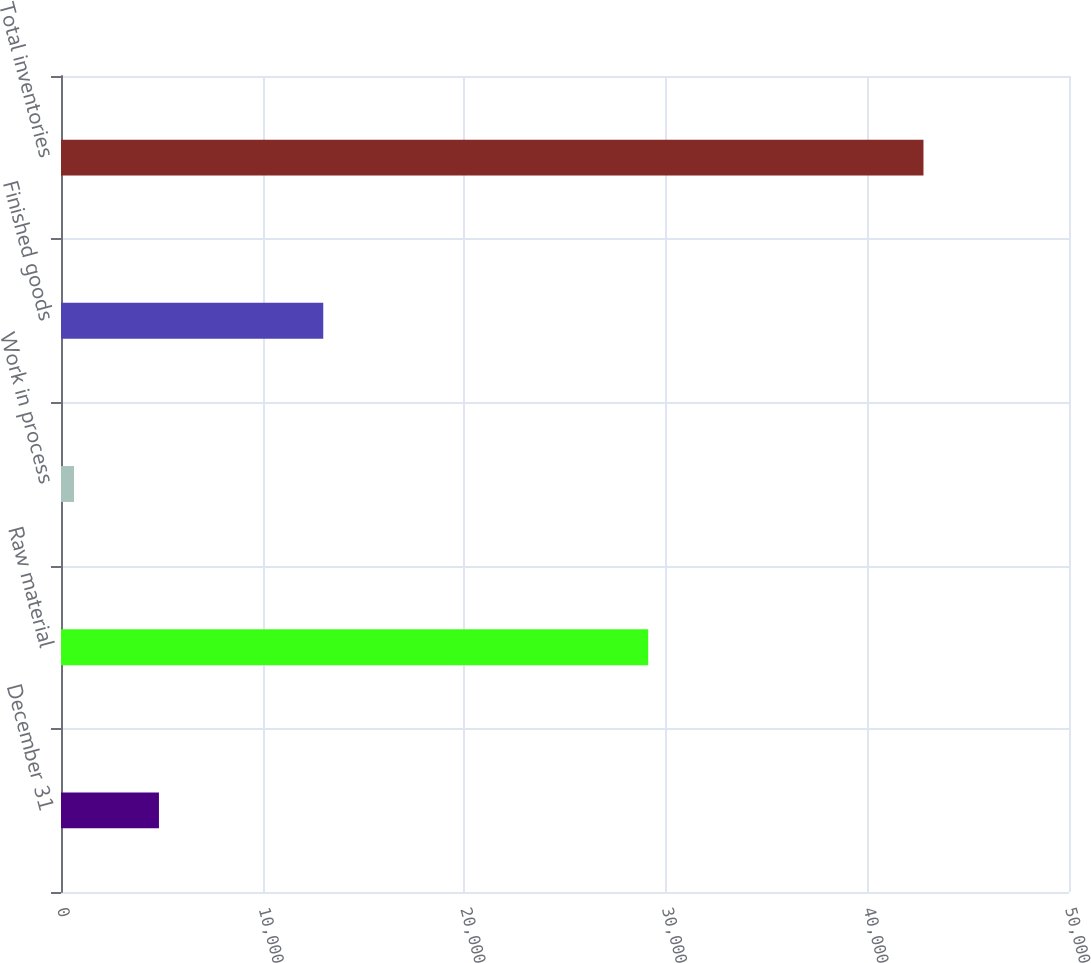Convert chart. <chart><loc_0><loc_0><loc_500><loc_500><bar_chart><fcel>December 31<fcel>Raw material<fcel>Work in process<fcel>Finished goods<fcel>Total inventories<nl><fcel>4858.6<fcel>29127<fcel>645<fcel>13009<fcel>42781<nl></chart> 